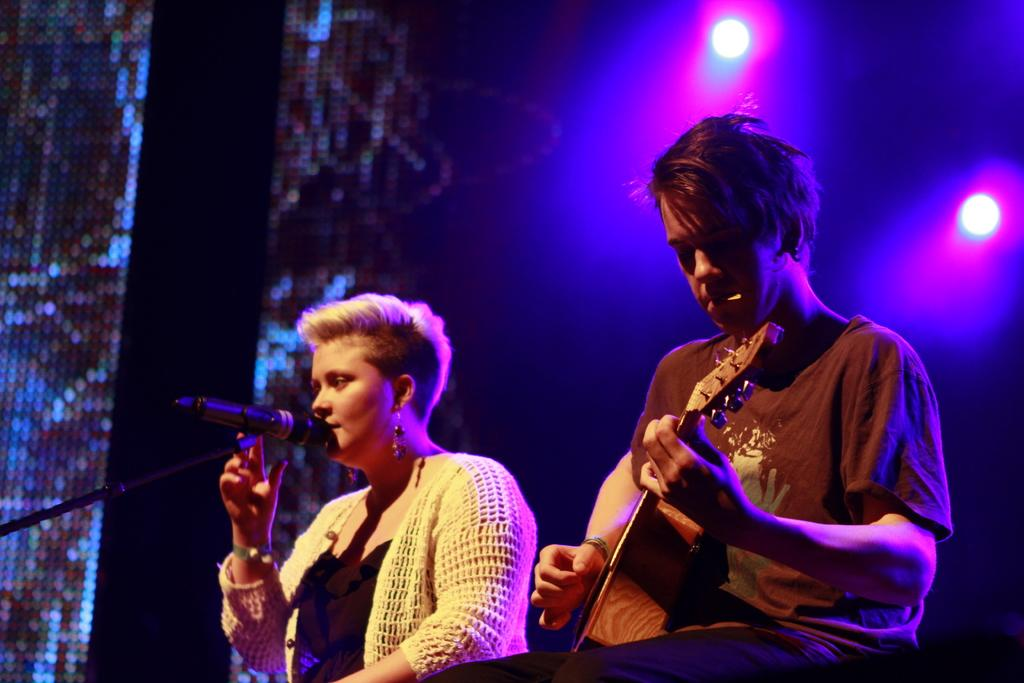How many people are in the image? There are two persons in the image. What is the man doing in the image? The man is playing a guitar. On which side of the image is the man located? The man is on the right side of the image. What is the woman doing in the image? The woman is singing into a microphone. On which side of the image is the woman located? The woman is on the left side of the image. What can be seen in the background? There is a light visible in the background. What type of design is the woman teaching in the image? There is no design or teaching activity present in the image. 